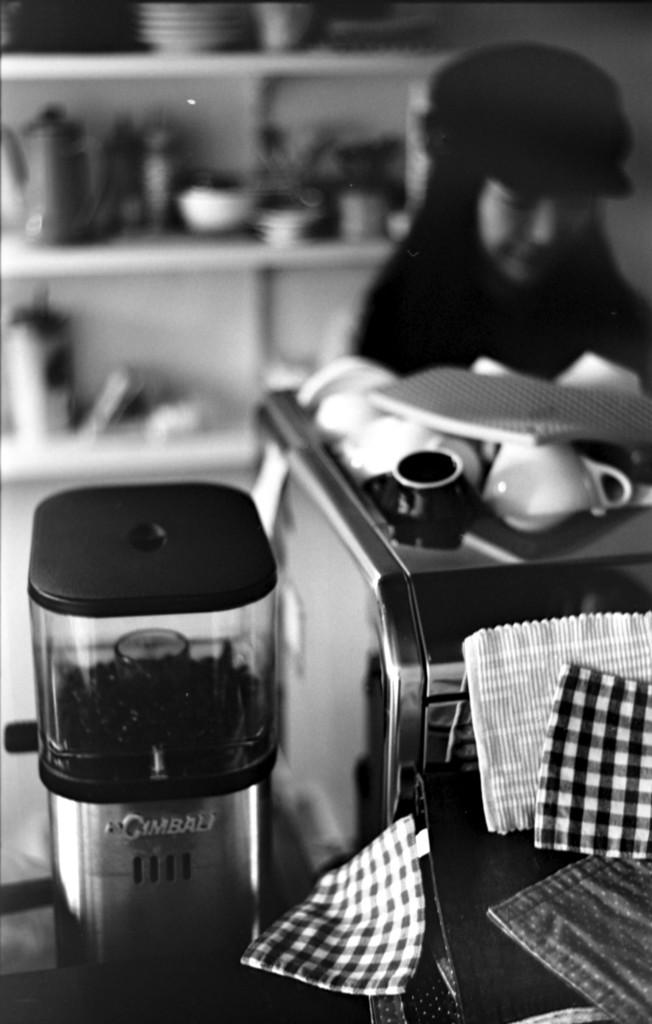<image>
Describe the image concisely. A coffee bean grinder with Cimbali on the front stands next to a coffee cup holder. 